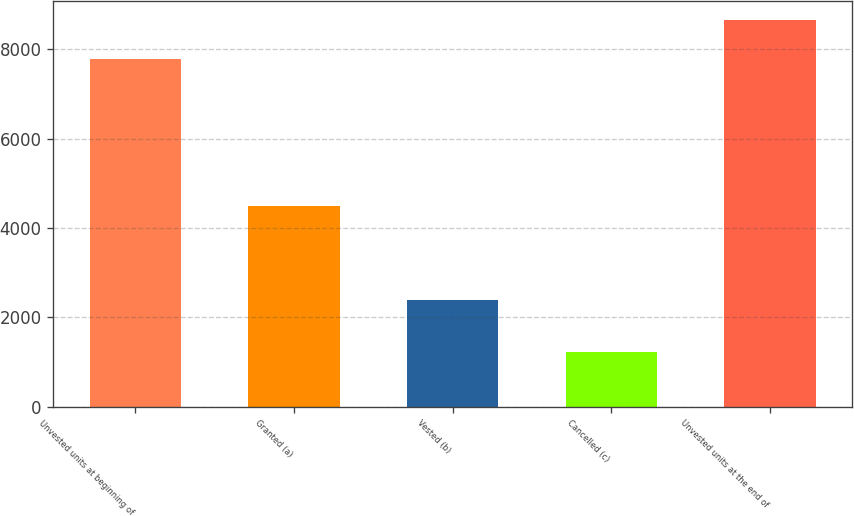Convert chart. <chart><loc_0><loc_0><loc_500><loc_500><bar_chart><fcel>Unvested units at beginning of<fcel>Granted (a)<fcel>Vested (b)<fcel>Cancelled (c)<fcel>Unvested units at the end of<nl><fcel>7773<fcel>4502<fcel>2387<fcel>1236<fcel>8652<nl></chart> 